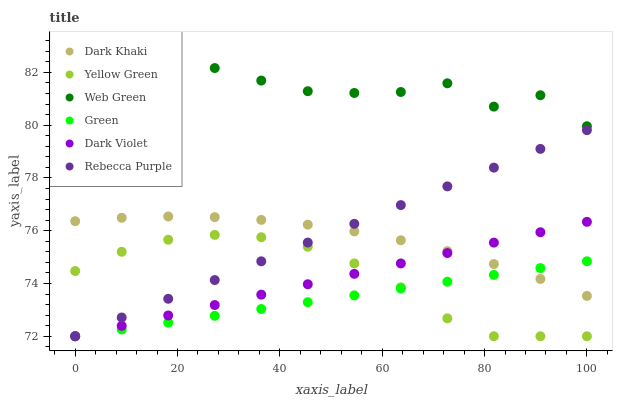Does Green have the minimum area under the curve?
Answer yes or no. Yes. Does Web Green have the maximum area under the curve?
Answer yes or no. Yes. Does Dark Violet have the minimum area under the curve?
Answer yes or no. No. Does Dark Violet have the maximum area under the curve?
Answer yes or no. No. Is Rebecca Purple the smoothest?
Answer yes or no. Yes. Is Web Green the roughest?
Answer yes or no. Yes. Is Dark Violet the smoothest?
Answer yes or no. No. Is Dark Violet the roughest?
Answer yes or no. No. Does Yellow Green have the lowest value?
Answer yes or no. Yes. Does Dark Khaki have the lowest value?
Answer yes or no. No. Does Web Green have the highest value?
Answer yes or no. Yes. Does Dark Violet have the highest value?
Answer yes or no. No. Is Dark Violet less than Web Green?
Answer yes or no. Yes. Is Dark Khaki greater than Yellow Green?
Answer yes or no. Yes. Does Yellow Green intersect Dark Violet?
Answer yes or no. Yes. Is Yellow Green less than Dark Violet?
Answer yes or no. No. Is Yellow Green greater than Dark Violet?
Answer yes or no. No. Does Dark Violet intersect Web Green?
Answer yes or no. No. 